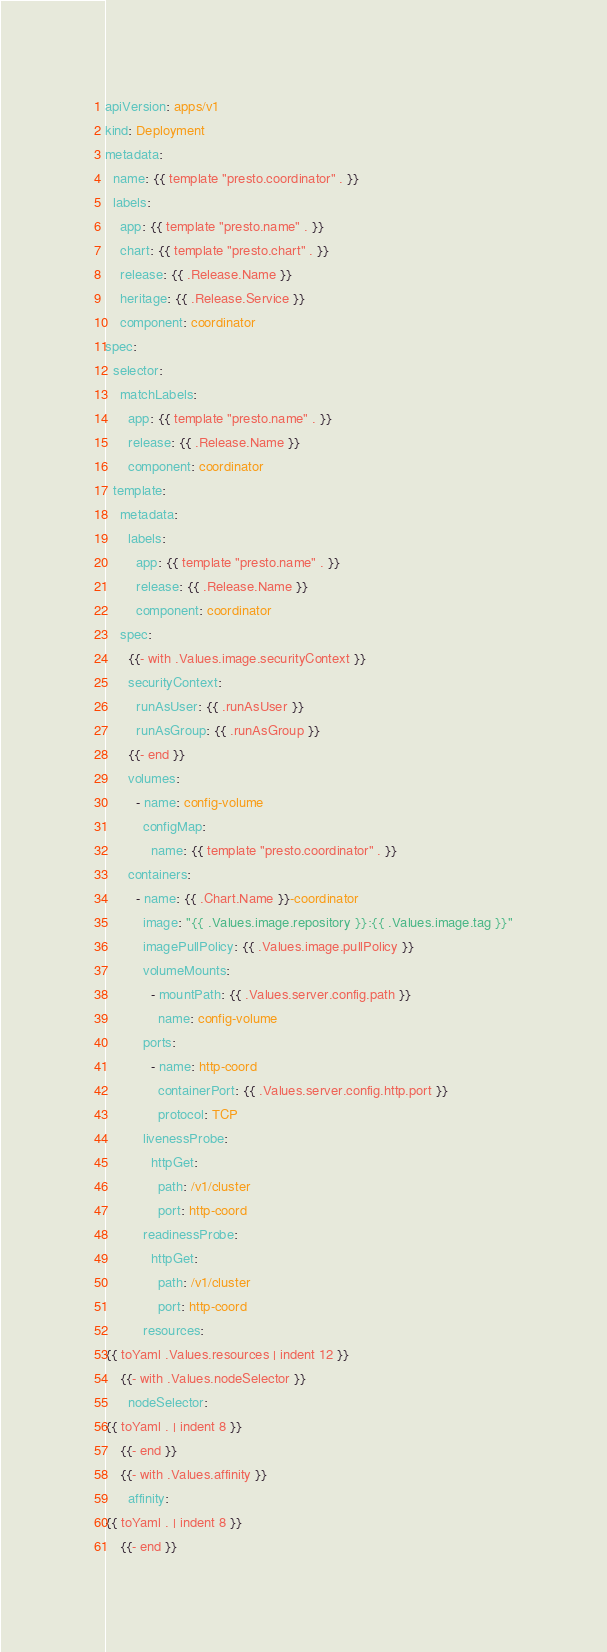Convert code to text. <code><loc_0><loc_0><loc_500><loc_500><_YAML_>apiVersion: apps/v1
kind: Deployment
metadata:
  name: {{ template "presto.coordinator" . }}
  labels:
    app: {{ template "presto.name" . }}
    chart: {{ template "presto.chart" . }}
    release: {{ .Release.Name }}
    heritage: {{ .Release.Service }}
    component: coordinator
spec:
  selector:
    matchLabels:
      app: {{ template "presto.name" . }}
      release: {{ .Release.Name }}
      component: coordinator
  template:
    metadata:
      labels:
        app: {{ template "presto.name" . }}
        release: {{ .Release.Name }}
        component: coordinator
    spec:
      {{- with .Values.image.securityContext }}
      securityContext:
        runAsUser: {{ .runAsUser }}
        runAsGroup: {{ .runAsGroup }}
      {{- end }}
      volumes:
        - name: config-volume
          configMap:
            name: {{ template "presto.coordinator" . }}
      containers:
        - name: {{ .Chart.Name }}-coordinator
          image: "{{ .Values.image.repository }}:{{ .Values.image.tag }}"
          imagePullPolicy: {{ .Values.image.pullPolicy }}
          volumeMounts:
            - mountPath: {{ .Values.server.config.path }}
              name: config-volume
          ports:
            - name: http-coord
              containerPort: {{ .Values.server.config.http.port }}
              protocol: TCP
          livenessProbe:
            httpGet:
              path: /v1/cluster
              port: http-coord
          readinessProbe:
            httpGet:
              path: /v1/cluster
              port: http-coord
          resources:
{{ toYaml .Values.resources | indent 12 }}
    {{- with .Values.nodeSelector }}
      nodeSelector:
{{ toYaml . | indent 8 }}
    {{- end }}
    {{- with .Values.affinity }}
      affinity:
{{ toYaml . | indent 8 }}
    {{- end }}</code> 